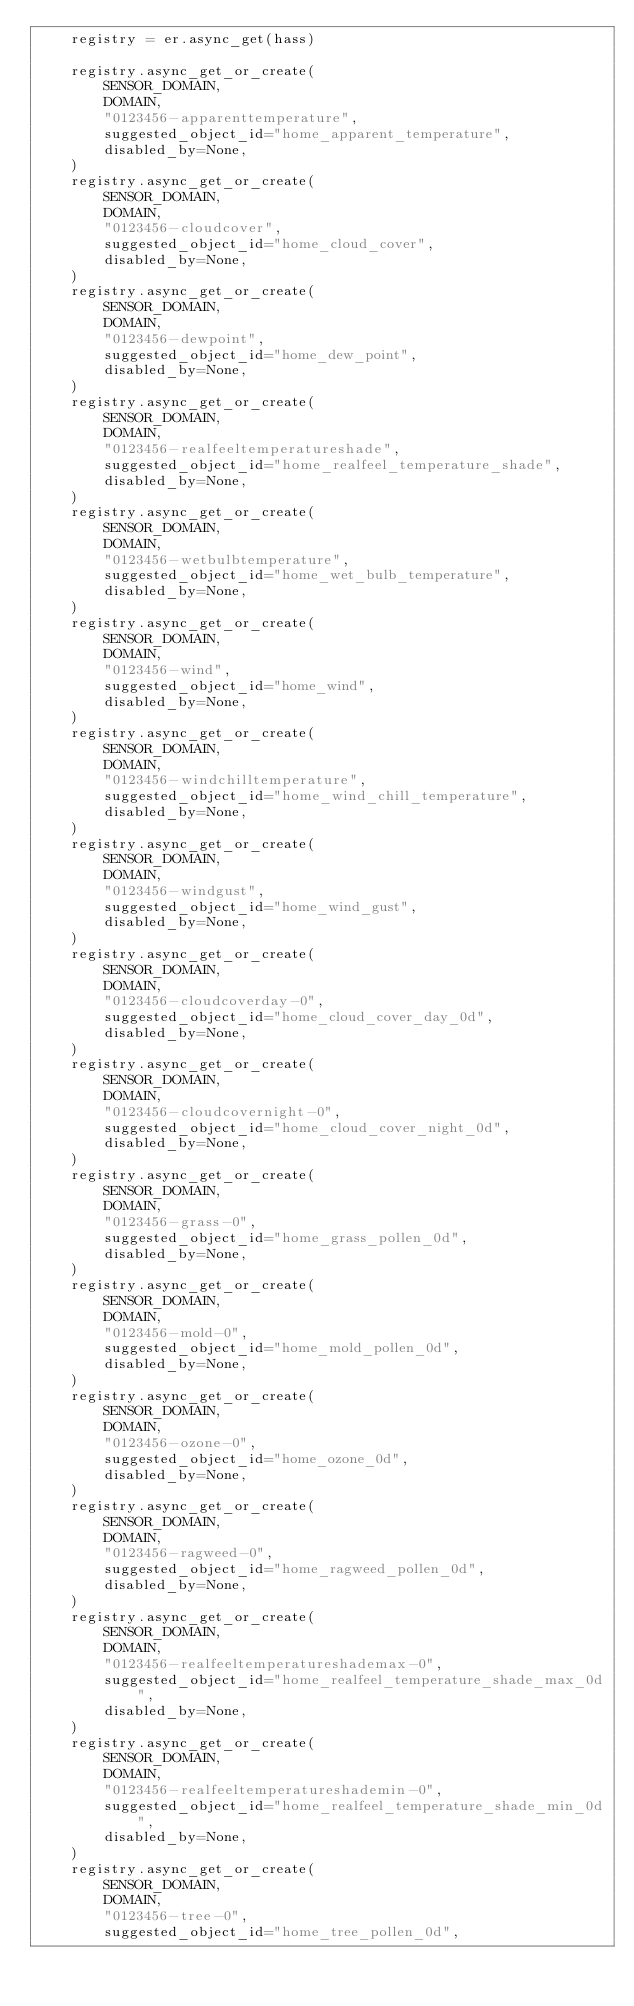Convert code to text. <code><loc_0><loc_0><loc_500><loc_500><_Python_>    registry = er.async_get(hass)

    registry.async_get_or_create(
        SENSOR_DOMAIN,
        DOMAIN,
        "0123456-apparenttemperature",
        suggested_object_id="home_apparent_temperature",
        disabled_by=None,
    )
    registry.async_get_or_create(
        SENSOR_DOMAIN,
        DOMAIN,
        "0123456-cloudcover",
        suggested_object_id="home_cloud_cover",
        disabled_by=None,
    )
    registry.async_get_or_create(
        SENSOR_DOMAIN,
        DOMAIN,
        "0123456-dewpoint",
        suggested_object_id="home_dew_point",
        disabled_by=None,
    )
    registry.async_get_or_create(
        SENSOR_DOMAIN,
        DOMAIN,
        "0123456-realfeeltemperatureshade",
        suggested_object_id="home_realfeel_temperature_shade",
        disabled_by=None,
    )
    registry.async_get_or_create(
        SENSOR_DOMAIN,
        DOMAIN,
        "0123456-wetbulbtemperature",
        suggested_object_id="home_wet_bulb_temperature",
        disabled_by=None,
    )
    registry.async_get_or_create(
        SENSOR_DOMAIN,
        DOMAIN,
        "0123456-wind",
        suggested_object_id="home_wind",
        disabled_by=None,
    )
    registry.async_get_or_create(
        SENSOR_DOMAIN,
        DOMAIN,
        "0123456-windchilltemperature",
        suggested_object_id="home_wind_chill_temperature",
        disabled_by=None,
    )
    registry.async_get_or_create(
        SENSOR_DOMAIN,
        DOMAIN,
        "0123456-windgust",
        suggested_object_id="home_wind_gust",
        disabled_by=None,
    )
    registry.async_get_or_create(
        SENSOR_DOMAIN,
        DOMAIN,
        "0123456-cloudcoverday-0",
        suggested_object_id="home_cloud_cover_day_0d",
        disabled_by=None,
    )
    registry.async_get_or_create(
        SENSOR_DOMAIN,
        DOMAIN,
        "0123456-cloudcovernight-0",
        suggested_object_id="home_cloud_cover_night_0d",
        disabled_by=None,
    )
    registry.async_get_or_create(
        SENSOR_DOMAIN,
        DOMAIN,
        "0123456-grass-0",
        suggested_object_id="home_grass_pollen_0d",
        disabled_by=None,
    )
    registry.async_get_or_create(
        SENSOR_DOMAIN,
        DOMAIN,
        "0123456-mold-0",
        suggested_object_id="home_mold_pollen_0d",
        disabled_by=None,
    )
    registry.async_get_or_create(
        SENSOR_DOMAIN,
        DOMAIN,
        "0123456-ozone-0",
        suggested_object_id="home_ozone_0d",
        disabled_by=None,
    )
    registry.async_get_or_create(
        SENSOR_DOMAIN,
        DOMAIN,
        "0123456-ragweed-0",
        suggested_object_id="home_ragweed_pollen_0d",
        disabled_by=None,
    )
    registry.async_get_or_create(
        SENSOR_DOMAIN,
        DOMAIN,
        "0123456-realfeeltemperatureshademax-0",
        suggested_object_id="home_realfeel_temperature_shade_max_0d",
        disabled_by=None,
    )
    registry.async_get_or_create(
        SENSOR_DOMAIN,
        DOMAIN,
        "0123456-realfeeltemperatureshademin-0",
        suggested_object_id="home_realfeel_temperature_shade_min_0d",
        disabled_by=None,
    )
    registry.async_get_or_create(
        SENSOR_DOMAIN,
        DOMAIN,
        "0123456-tree-0",
        suggested_object_id="home_tree_pollen_0d",</code> 